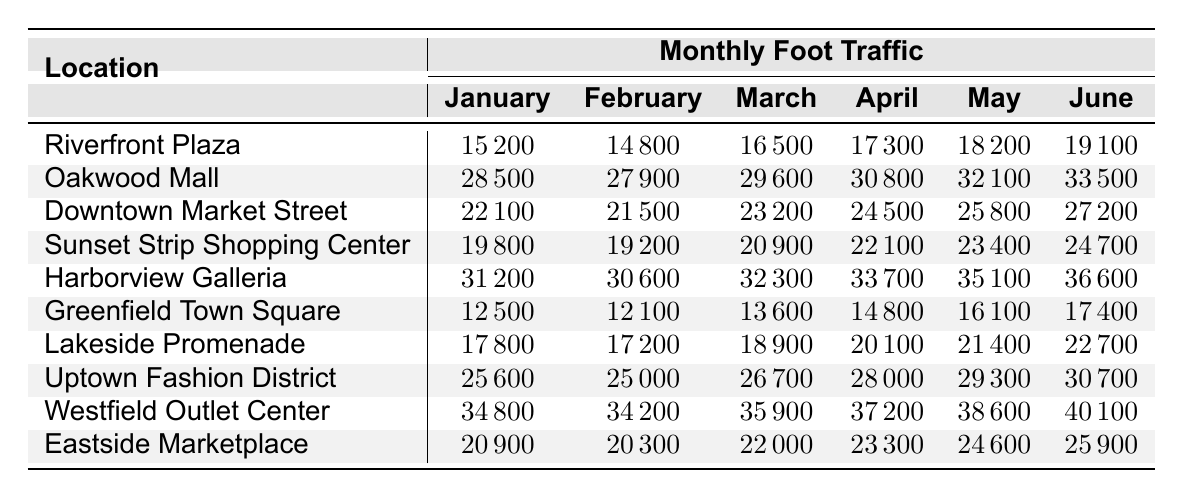What is the foot traffic for Oakwood Mall in May? Oakwood Mall shows a foot traffic count of 32,100 for May according to the table.
Answer: 32100 Which location had the highest foot traffic in April? In April, Westfield Outlet Center had the highest foot traffic with a count of 37,200.
Answer: 37200 What is the average foot traffic for Downtown Market Street from January to June? The total foot traffic for Downtown Market Street over these months is (22,100 + 21,500 + 23,200 + 24,500 + 25,800 + 27,200) = 144,300. Dividing by 6 gives an average of 24,050.
Answer: 24050 Did Harborview Galleria consistently increase in foot traffic from January to June? Yes, Harborview Galleria shows a consistent increase in foot traffic each month from 31,200 in January to 36,600 in June.
Answer: Yes What was the difference in foot traffic between the worst and best month for Greenfield Town Square? The worst month for Greenfield Town Square was January with 12,500 foot traffic and the best month was June with 17,400. The difference is 17,400 - 12,500 = 4,900.
Answer: 4900 Which location had the lowest foot traffic in February? Greenfield Town Square recorded the lowest foot traffic in February with 12,100.
Answer: 12100 What was the total foot traffic for Lakeside Promenade over the six months? The total foot traffic for Lakeside Promenade is calculated as (17,800 + 17,200 + 18,900 + 20,100 + 21,400 + 22,700) = 117,100.
Answer: 117100 Is it true that all locations had more than 20,000 foot traffic in March? No, not all locations had more than 20,000. Greenfield Town Square had only 13,600 in March.
Answer: No Which location experienced the largest increase in foot traffic from May to June? The largest increase from May to June was observed in Westfield Outlet Center, which increased from 38,600 to 40,100, an increase of 1,500.
Answer: 1500 What is the foot traffic trend for Riverfront Plaza from January to June? Riverfront Plaza shows a trend of increasing foot traffic, starting from 15,200 in January and rising to 19,100 in June.
Answer: Increasing 